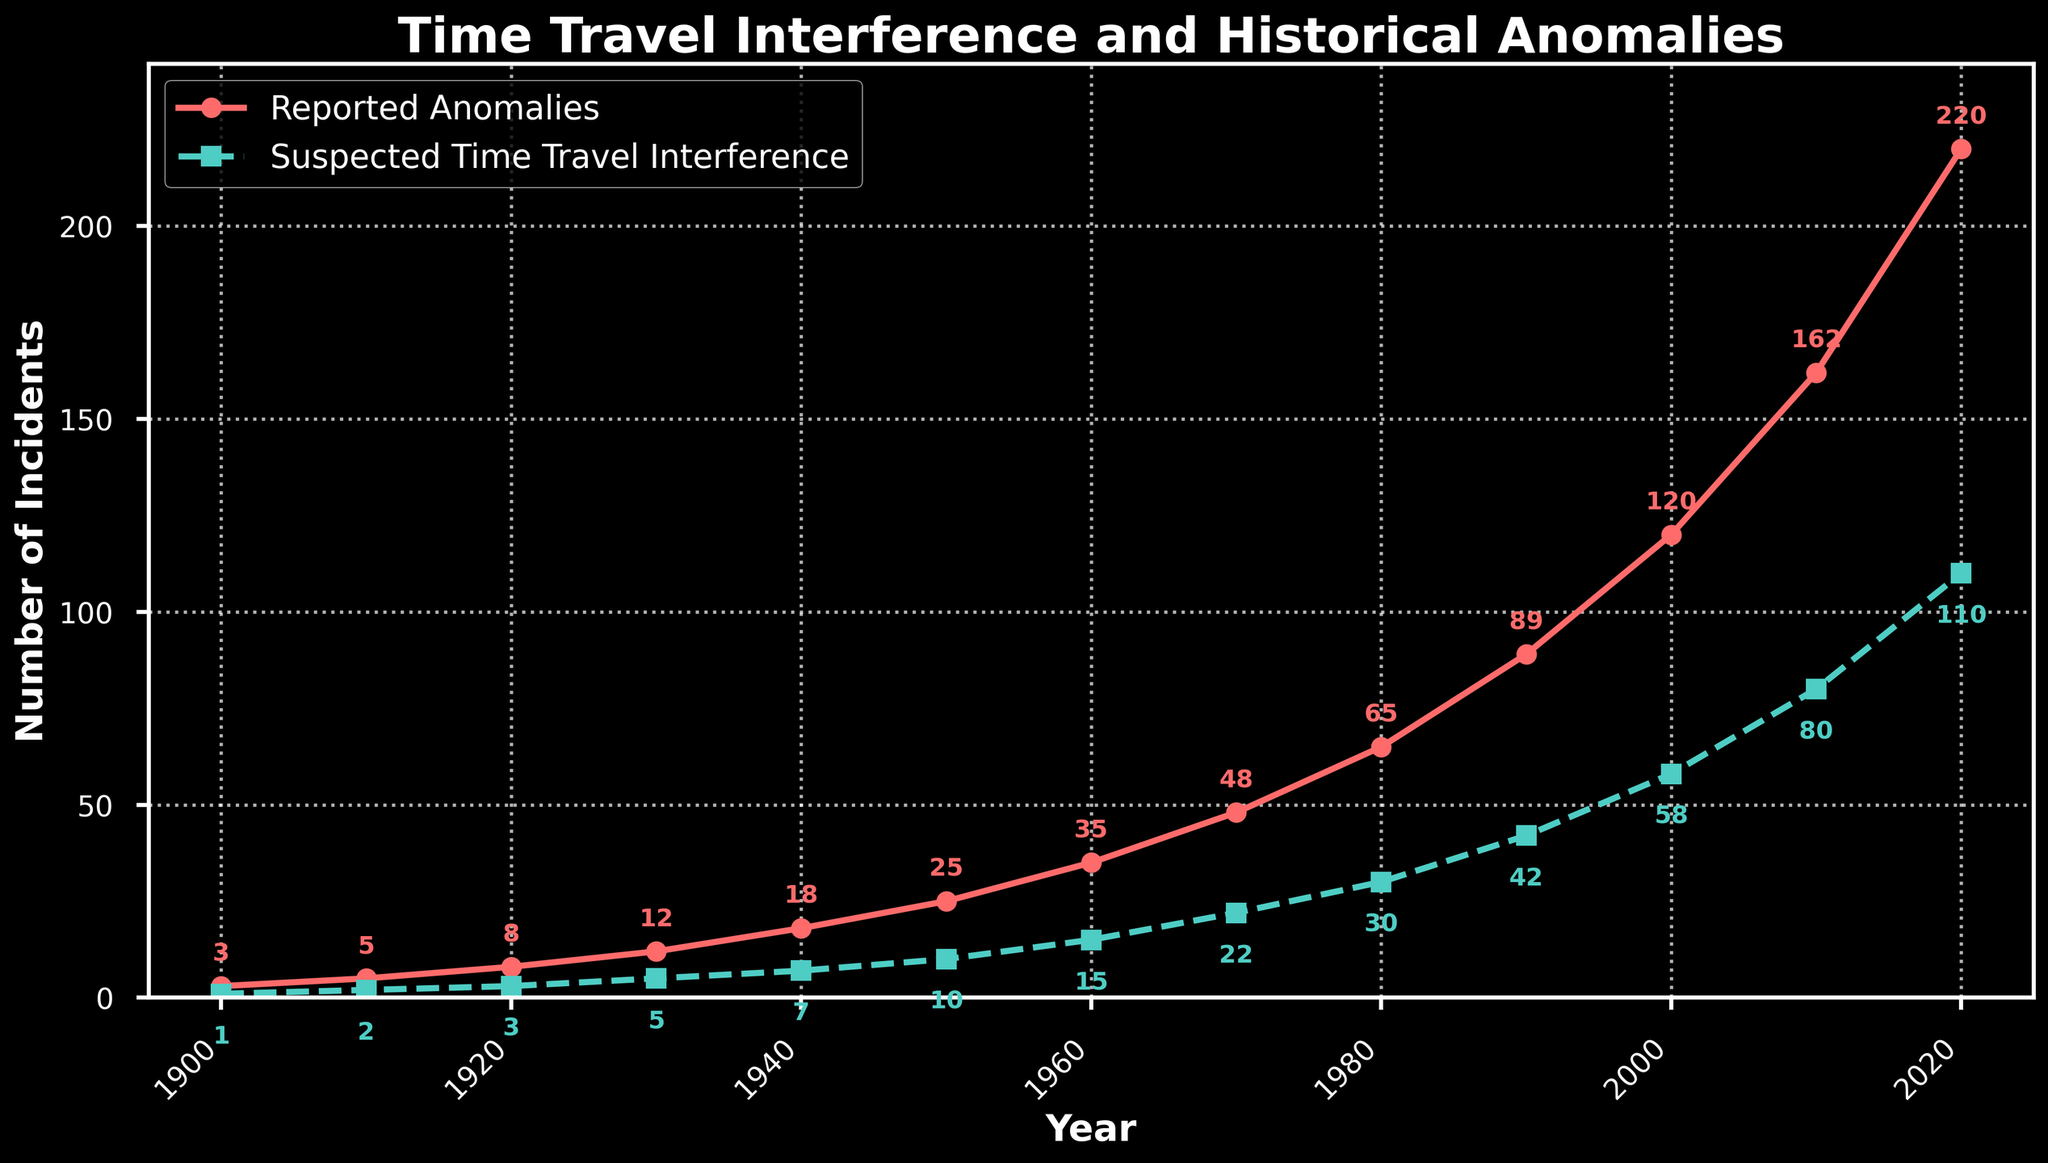What is the difference between the reported anomalies and suspected time travel interference for the year 2020? Look at the point corresponding to the year 2020 on the figure. The reported anomalies are 220 and suspected time travel interference is 110. The difference is 220 - 110.
Answer: 110 How many more reported anomalies are there in 2000 compared to 1960? Find the values for reported anomalies in 2000 and 1960 on the chart. In 2000, it is 120, and in 1960, it is 35. The difference is 120 - 35.
Answer: 85 Which year saw the highest increase in suspected time travel interference compared to the previous decade? Compare the increments between each decade for suspected time travel interference: (1910-1900: 2-1=1), (1920-1910: 3-2=1), (1930-1920: 5-3=2), (1940-1930: 7-5=2), (1950-1940: 10-7=3), (1960-1950: 15-10=5), (1970-1960: 22-15=7), (1980-1970: 30-22=8), (1990-1980: 42-30=12), (2000-1990: 58-42=16), (2010-2000: 80-58=22), (2020-2010: 110-80=30). The highest increase occurred between 2010 and 2020.
Answer: 2020 What is the average number of reported anomalies from 1900 to 2020? Sum all the reported anomalies from the data (3 + 5 + 8 + 12 + 18 + 25 + 35 + 48 + 65 + 89 + 120 + 162 + 220 = 810) and divide by the number of data points (13). The average is 810 / 13.
Answer: 62.31 Is there a year where the number of reported anomalies and suspected time travel interference is equal? Examine the chart to see if there is any overlap between the reported anomalies and suspected time travel interference. None of the points intersect.
Answer: No How does the trend in reported anomalies compare to the trend in suspected time travel interference from 1900 to 2020? Both trends increase over time, but the rate of increase for reported anomalies is steeper than for suspected time travel interference. This suggests a stronger increase in reported anomalies relative to suspected time travel interference as time progresses.
Answer: Reported anomalies increase faster In which year did reported anomalies first exceed 100? Check the chart for the first year where the reported anomalies surpass 100. This happens in 2000.
Answer: 2000 What is the overall trend in suspected time travel interference from 1900 to 2020? Observing the line corresponding to suspected time travel interference, the number steadily increases, indicating an upward trend throughout the timeframe.
Answer: Upward trend Which year had the largest gap between reported anomalies and suspected time travel interference? Look at the difference values year by year and identify the year with the largest gap. In 2020, the difference (220-110) is the largest, which is 110.
Answer: 2020 